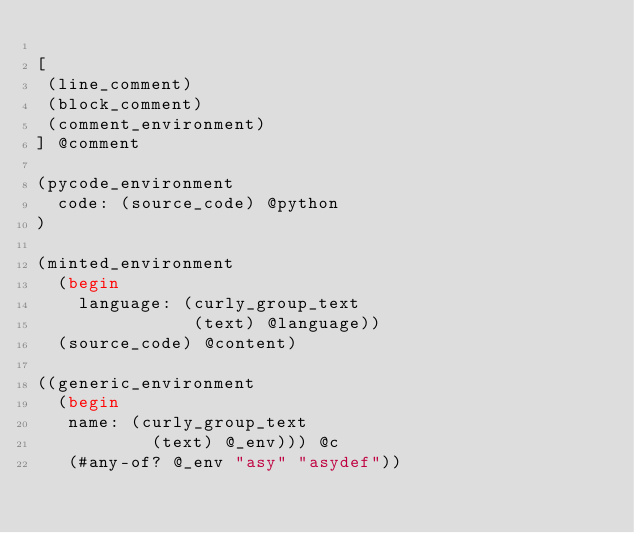<code> <loc_0><loc_0><loc_500><loc_500><_Scheme_>
[
 (line_comment)
 (block_comment)
 (comment_environment)
] @comment

(pycode_environment
  code: (source_code) @python
)

(minted_environment
  (begin
    language: (curly_group_text
               (text) @language))
  (source_code) @content)

((generic_environment
  (begin
   name: (curly_group_text
           (text) @_env))) @c
   (#any-of? @_env "asy" "asydef"))
</code> 